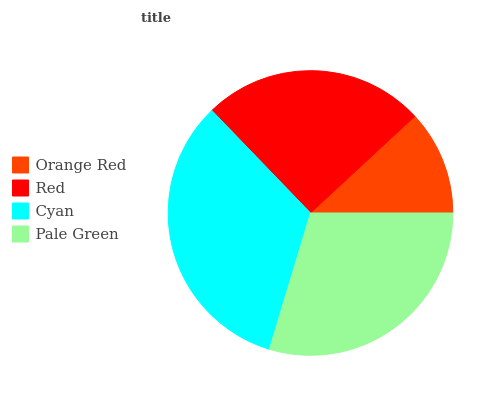Is Orange Red the minimum?
Answer yes or no. Yes. Is Cyan the maximum?
Answer yes or no. Yes. Is Red the minimum?
Answer yes or no. No. Is Red the maximum?
Answer yes or no. No. Is Red greater than Orange Red?
Answer yes or no. Yes. Is Orange Red less than Red?
Answer yes or no. Yes. Is Orange Red greater than Red?
Answer yes or no. No. Is Red less than Orange Red?
Answer yes or no. No. Is Pale Green the high median?
Answer yes or no. Yes. Is Red the low median?
Answer yes or no. Yes. Is Red the high median?
Answer yes or no. No. Is Cyan the low median?
Answer yes or no. No. 